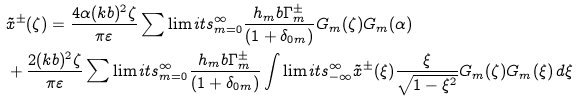<formula> <loc_0><loc_0><loc_500><loc_500>& \tilde { x } ^ { \pm } ( \zeta ) = \frac { 4 \alpha ( k b ) ^ { 2 } \zeta } { \pi \varepsilon } \sum \lim i t s _ { m = 0 } ^ { \infty } \frac { h _ { m } b \Gamma _ { m } ^ { \pm } } { ( 1 + \delta _ { 0 m } ) } G _ { m } ( \zeta ) G _ { m } ( \alpha ) \\ & + \frac { 2 ( k b ) ^ { 2 } \zeta } { \pi \varepsilon } \sum \lim i t s _ { m = 0 } ^ { \infty } \frac { h _ { m } b \Gamma _ { m } ^ { \pm } } { ( 1 + \delta _ { 0 m } ) } \int \lim i t s _ { - \infty } ^ { \infty } \tilde { x } ^ { \pm } ( \xi ) \frac { \xi } { \sqrt { 1 - \xi ^ { 2 } } } G _ { m } ( \zeta ) G _ { m } ( \xi ) \, d \xi</formula> 